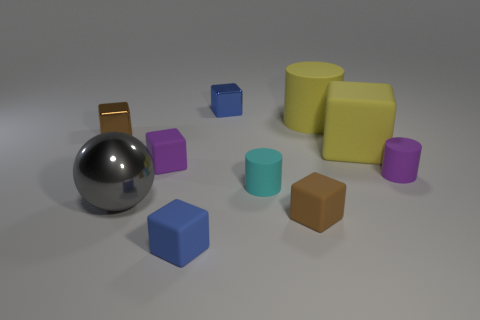There is a small brown thing that is behind the tiny matte thing on the right side of the large cylinder; is there a cylinder in front of it?
Provide a short and direct response. Yes. What color is the other big thing that is the same shape as the cyan rubber thing?
Provide a short and direct response. Yellow. What number of yellow objects are large cylinders or big metallic objects?
Provide a succinct answer. 1. There is a large object that is left of the purple thing left of the large yellow cube; what is it made of?
Your answer should be compact. Metal. Do the cyan matte object and the big gray thing have the same shape?
Give a very brief answer. No. There is a cylinder that is the same size as the cyan thing; what color is it?
Your answer should be very brief. Purple. Are there any metal cubes of the same color as the large cylinder?
Provide a succinct answer. No. Are there any small cyan balls?
Offer a terse response. No. Is the material of the blue object that is behind the big cube the same as the big gray sphere?
Provide a short and direct response. Yes. There is a thing that is the same color as the large matte cylinder; what is its size?
Your answer should be very brief. Large. 